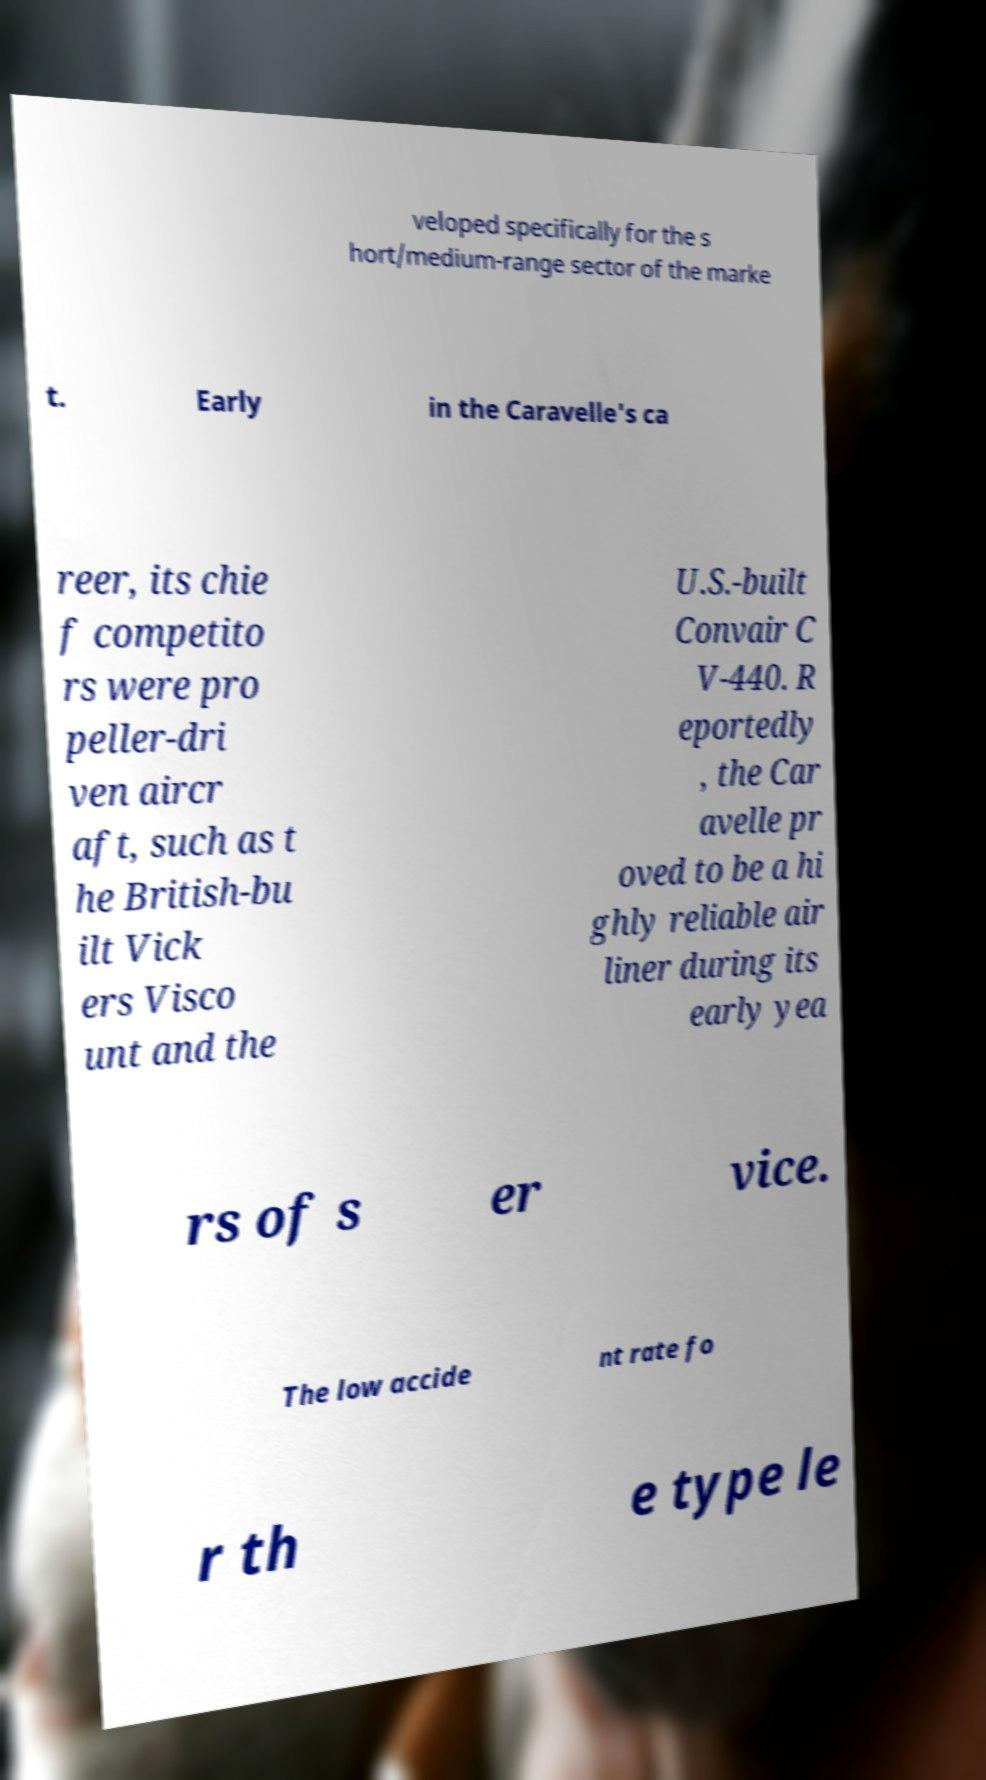There's text embedded in this image that I need extracted. Can you transcribe it verbatim? veloped specifically for the s hort/medium-range sector of the marke t. Early in the Caravelle's ca reer, its chie f competito rs were pro peller-dri ven aircr aft, such as t he British-bu ilt Vick ers Visco unt and the U.S.-built Convair C V-440. R eportedly , the Car avelle pr oved to be a hi ghly reliable air liner during its early yea rs of s er vice. The low accide nt rate fo r th e type le 